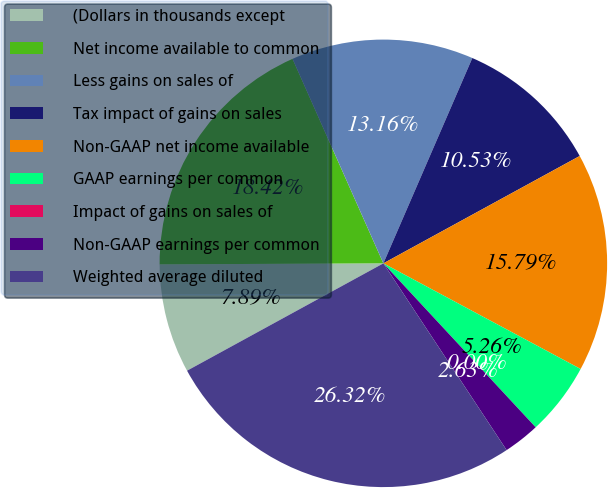Convert chart to OTSL. <chart><loc_0><loc_0><loc_500><loc_500><pie_chart><fcel>(Dollars in thousands except<fcel>Net income available to common<fcel>Less gains on sales of<fcel>Tax impact of gains on sales<fcel>Non-GAAP net income available<fcel>GAAP earnings per common<fcel>Impact of gains on sales of<fcel>Non-GAAP earnings per common<fcel>Weighted average diluted<nl><fcel>7.89%<fcel>18.42%<fcel>13.16%<fcel>10.53%<fcel>15.79%<fcel>5.26%<fcel>0.0%<fcel>2.63%<fcel>26.32%<nl></chart> 